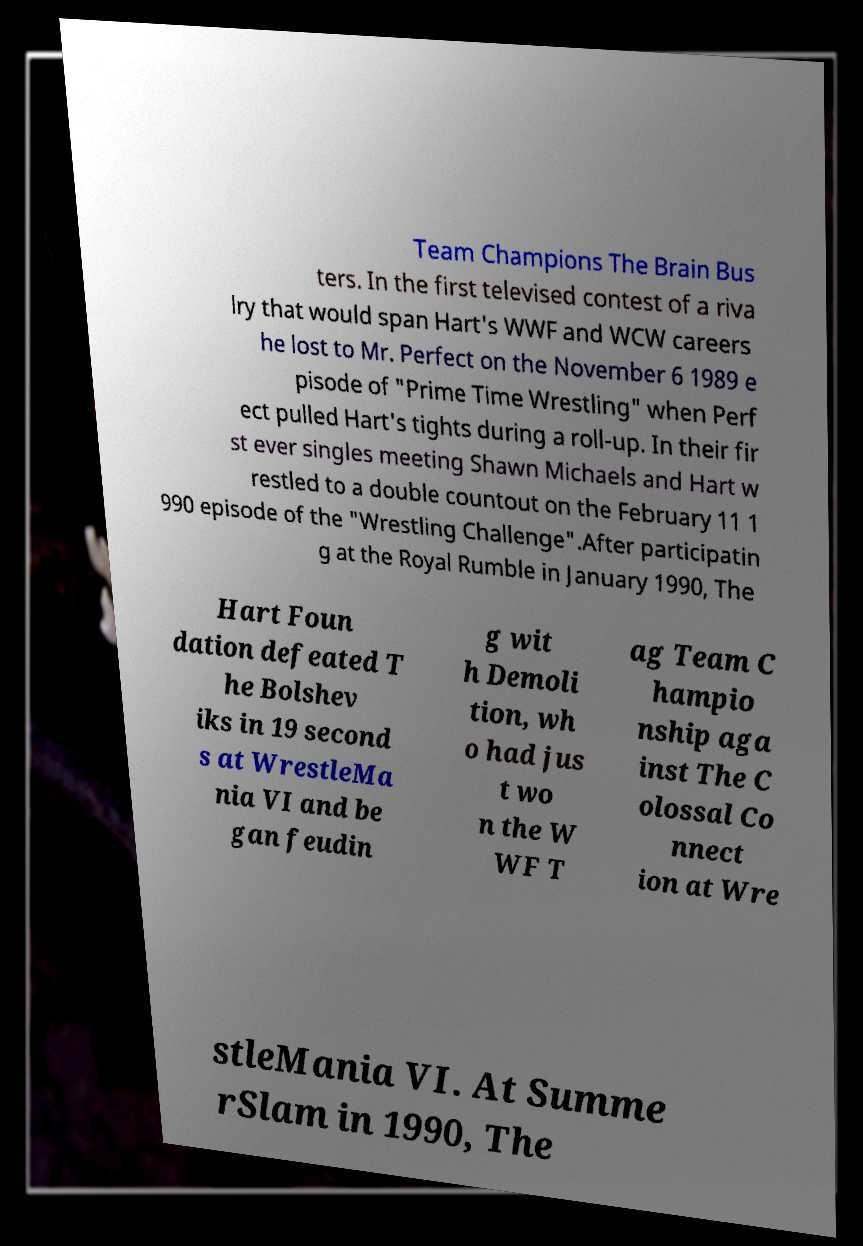Could you extract and type out the text from this image? Team Champions The Brain Bus ters. In the first televised contest of a riva lry that would span Hart's WWF and WCW careers he lost to Mr. Perfect on the November 6 1989 e pisode of "Prime Time Wrestling" when Perf ect pulled Hart's tights during a roll-up. In their fir st ever singles meeting Shawn Michaels and Hart w restled to a double countout on the February 11 1 990 episode of the "Wrestling Challenge".After participatin g at the Royal Rumble in January 1990, The Hart Foun dation defeated T he Bolshev iks in 19 second s at WrestleMa nia VI and be gan feudin g wit h Demoli tion, wh o had jus t wo n the W WF T ag Team C hampio nship aga inst The C olossal Co nnect ion at Wre stleMania VI. At Summe rSlam in 1990, The 